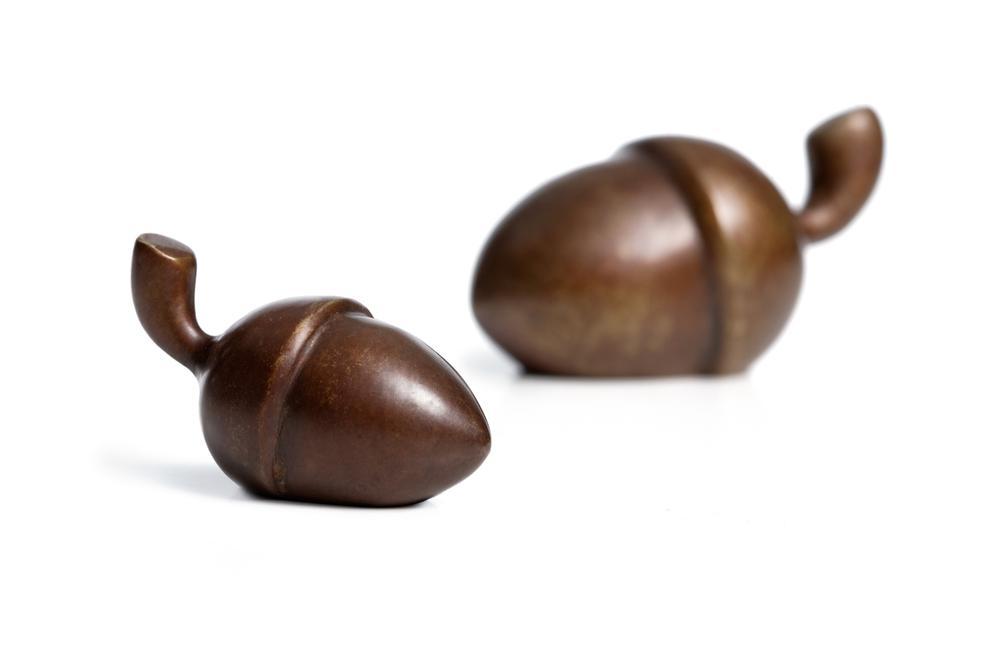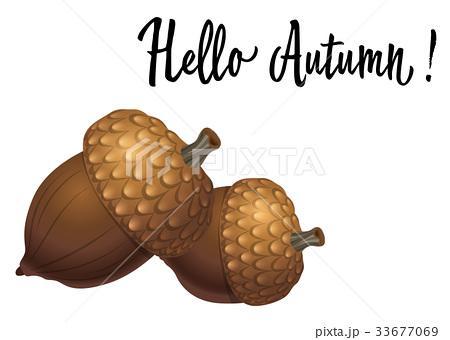The first image is the image on the left, the second image is the image on the right. Analyze the images presented: Is the assertion "Each image contains exactly two acorns with their caps on, and at least one of the images features acorns with caps back-to-back and joined at the stem top." valid? Answer yes or no. No. 